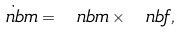<formula> <loc_0><loc_0><loc_500><loc_500>\dot { \ n b m } = { \ n b m } \times { \ n b f } ,</formula> 